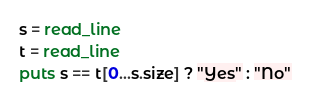Convert code to text. <code><loc_0><loc_0><loc_500><loc_500><_Crystal_>s = read_line
t = read_line
puts s == t[0...s.size] ? "Yes" : "No"
</code> 